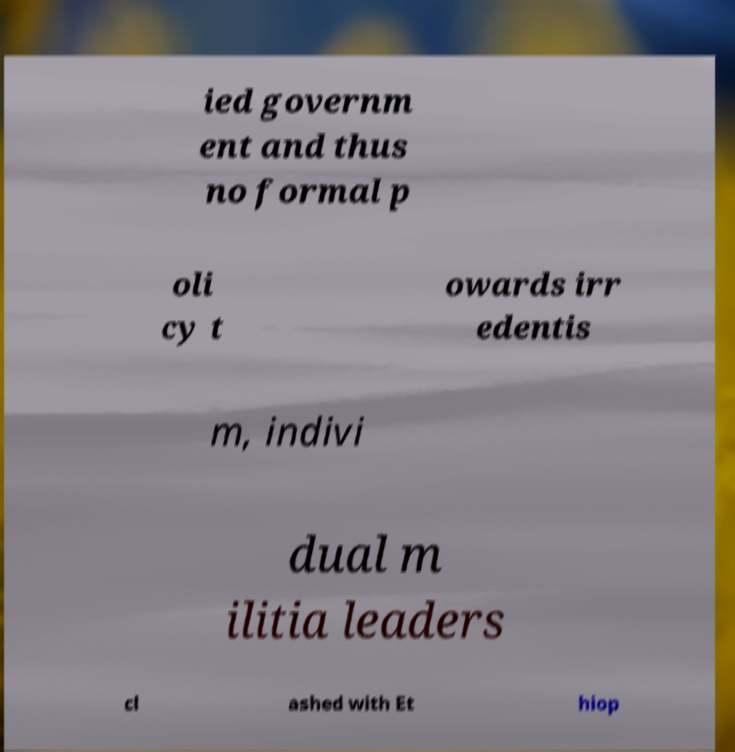Can you read and provide the text displayed in the image?This photo seems to have some interesting text. Can you extract and type it out for me? ied governm ent and thus no formal p oli cy t owards irr edentis m, indivi dual m ilitia leaders cl ashed with Et hiop 